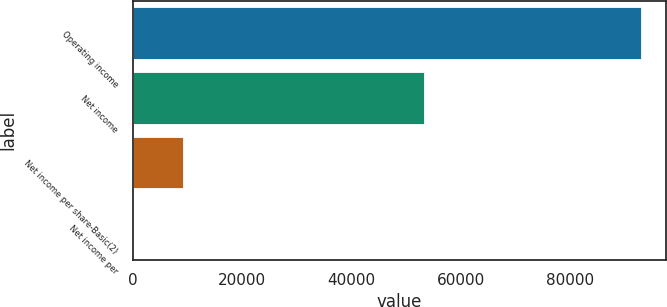Convert chart to OTSL. <chart><loc_0><loc_0><loc_500><loc_500><bar_chart><fcel>Operating income<fcel>Net income<fcel>Net income per share-Basic(2)<fcel>Net income per<nl><fcel>93010<fcel>53341<fcel>9301.26<fcel>0.29<nl></chart> 